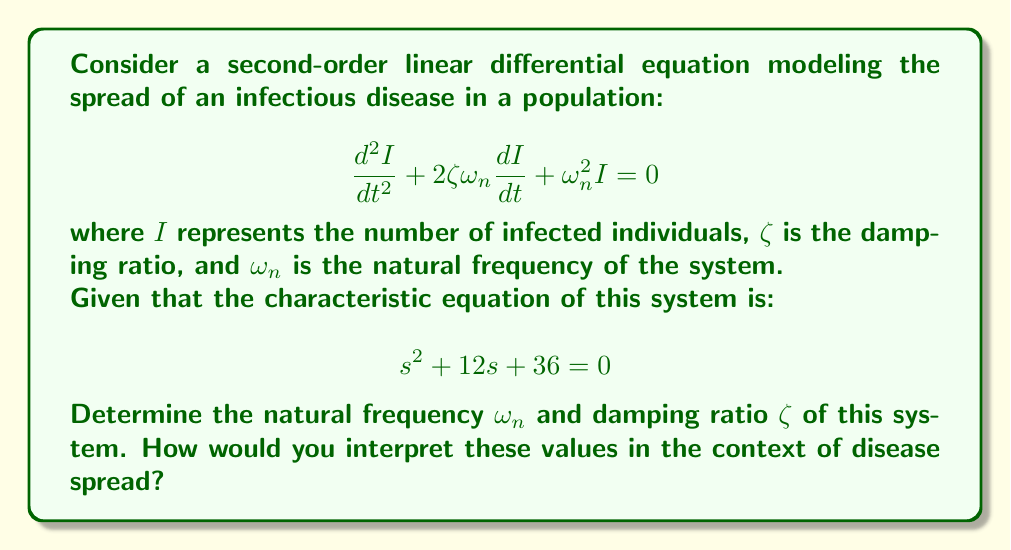Can you solve this math problem? To solve this problem, we'll follow these steps:

1) First, let's recall the general form of a second-order linear differential equation:

   $$\frac{d^2I}{dt^2} + 2\zeta\omega_n\frac{dI}{dt} + \omega_n^2I = 0$$

2) The characteristic equation for this system is given as:

   $$s^2 + 12s + 36 = 0$$

3) Comparing this with the general form of a characteristic equation:

   $$s^2 + 2\zeta\omega_ns + \omega_n^2 = 0$$

4) We can identify that:
   
   $2\zeta\omega_n = 12$
   $\omega_n^2 = 36$

5) From $\omega_n^2 = 36$, we can directly calculate $\omega_n$:
   
   $\omega_n = \sqrt{36} = 6$ rad/time unit

6) Now, we can calculate $\zeta$:
   
   $2\zeta\omega_n = 12$
   $2\zeta(6) = 12$
   $\zeta = \frac{12}{12} = 1$

7) Interpretation:
   - The natural frequency $\omega_n = 6$ rad/time unit represents the frequency at which the system would oscillate if there were no damping.
   - The damping ratio $\zeta = 1$ indicates that the system is critically damped. This means the disease spread will approach equilibrium as quickly as possible without oscillating.

In the context of disease spread:
- The natural frequency suggests how quickly the disease would spread in an ideal scenario.
- The critical damping indicates that the number of infected individuals will approach the equilibrium state (which could be zero for disease eradication) in the most efficient manner, without overshooting or oscillating.
Answer: $\omega_n = 6$ rad/time unit, $\zeta = 1$ 